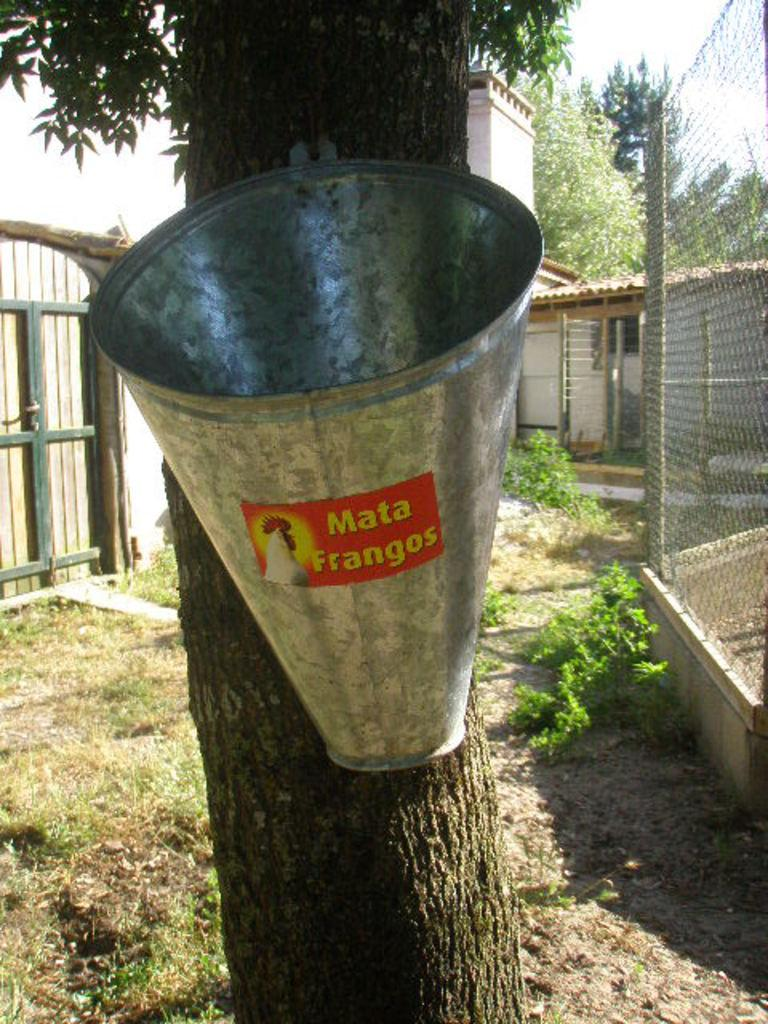What is hanging on the tree in the image? There is a bucket with a label hanging on a tree in the image. What can be seen in the background of the image? In the background of the image, there is grass, plants, a fence, a wooden door, a house, trees, and the sky. What might the bucket be used for? The bucket could be used for various purposes, such as collecting water or holding tools, but the specific use cannot be determined from the image alone. What type of health advice can be seen on the edge of the station in the image? There is no health advice or station present in the image; it features a bucket hanging on a tree and various elements in the background. 